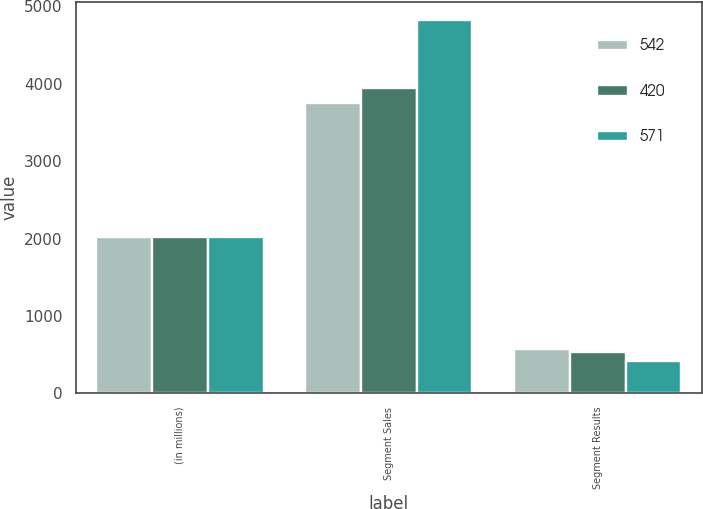Convert chart. <chart><loc_0><loc_0><loc_500><loc_500><stacked_bar_chart><ecel><fcel>(in millions)<fcel>Segment Sales<fcel>Segment Results<nl><fcel>542<fcel>2016<fcel>3756<fcel>571<nl><fcel>420<fcel>2015<fcel>3945<fcel>542<nl><fcel>571<fcel>2014<fcel>4817<fcel>420<nl></chart> 